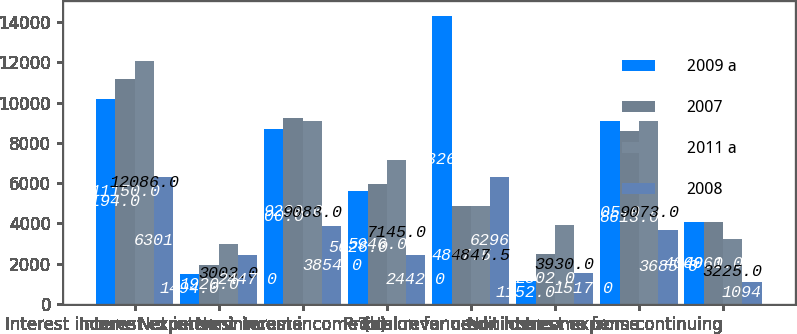<chart> <loc_0><loc_0><loc_500><loc_500><stacked_bar_chart><ecel><fcel>Interest income<fcel>Interest expense<fcel>Net interest income<fcel>Noninterest income (b)<fcel>Total revenue<fcel>Provision for credit losses<fcel>Noninterest expense<fcel>Income from continuing<nl><fcel>2009 a<fcel>10194<fcel>1494<fcel>8700<fcel>5626<fcel>14326<fcel>1152<fcel>9105<fcel>4069<nl><fcel>2007<fcel>11150<fcel>1920<fcel>9230<fcel>5946<fcel>4847.5<fcel>2502<fcel>8613<fcel>4061<nl><fcel>2011 a<fcel>12086<fcel>3003<fcel>9083<fcel>7145<fcel>4847.5<fcel>3930<fcel>9073<fcel>3225<nl><fcel>2008<fcel>6301<fcel>2447<fcel>3854<fcel>2442<fcel>6296<fcel>1517<fcel>3685<fcel>1094<nl></chart> 